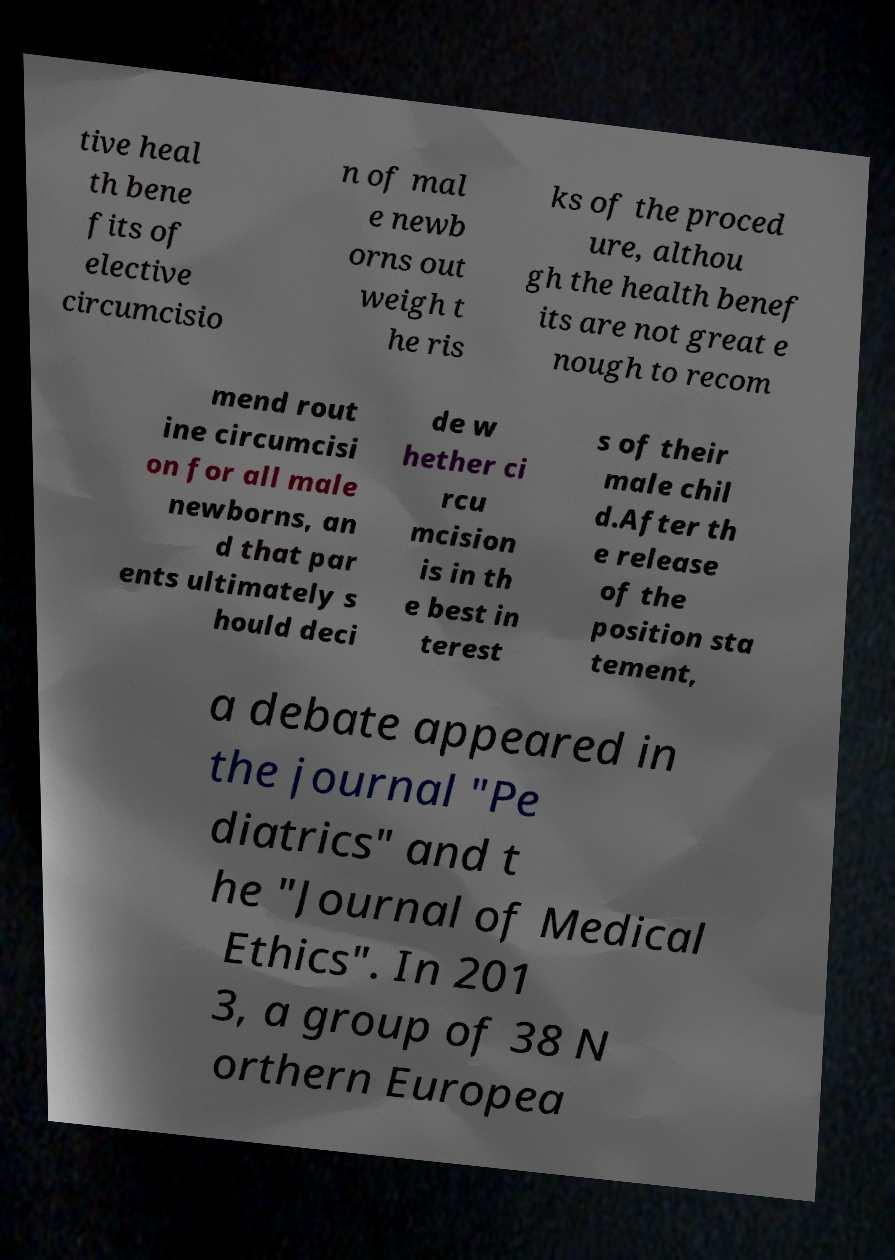Please read and relay the text visible in this image. What does it say? tive heal th bene fits of elective circumcisio n of mal e newb orns out weigh t he ris ks of the proced ure, althou gh the health benef its are not great e nough to recom mend rout ine circumcisi on for all male newborns, an d that par ents ultimately s hould deci de w hether ci rcu mcision is in th e best in terest s of their male chil d.After th e release of the position sta tement, a debate appeared in the journal "Pe diatrics" and t he "Journal of Medical Ethics". In 201 3, a group of 38 N orthern Europea 